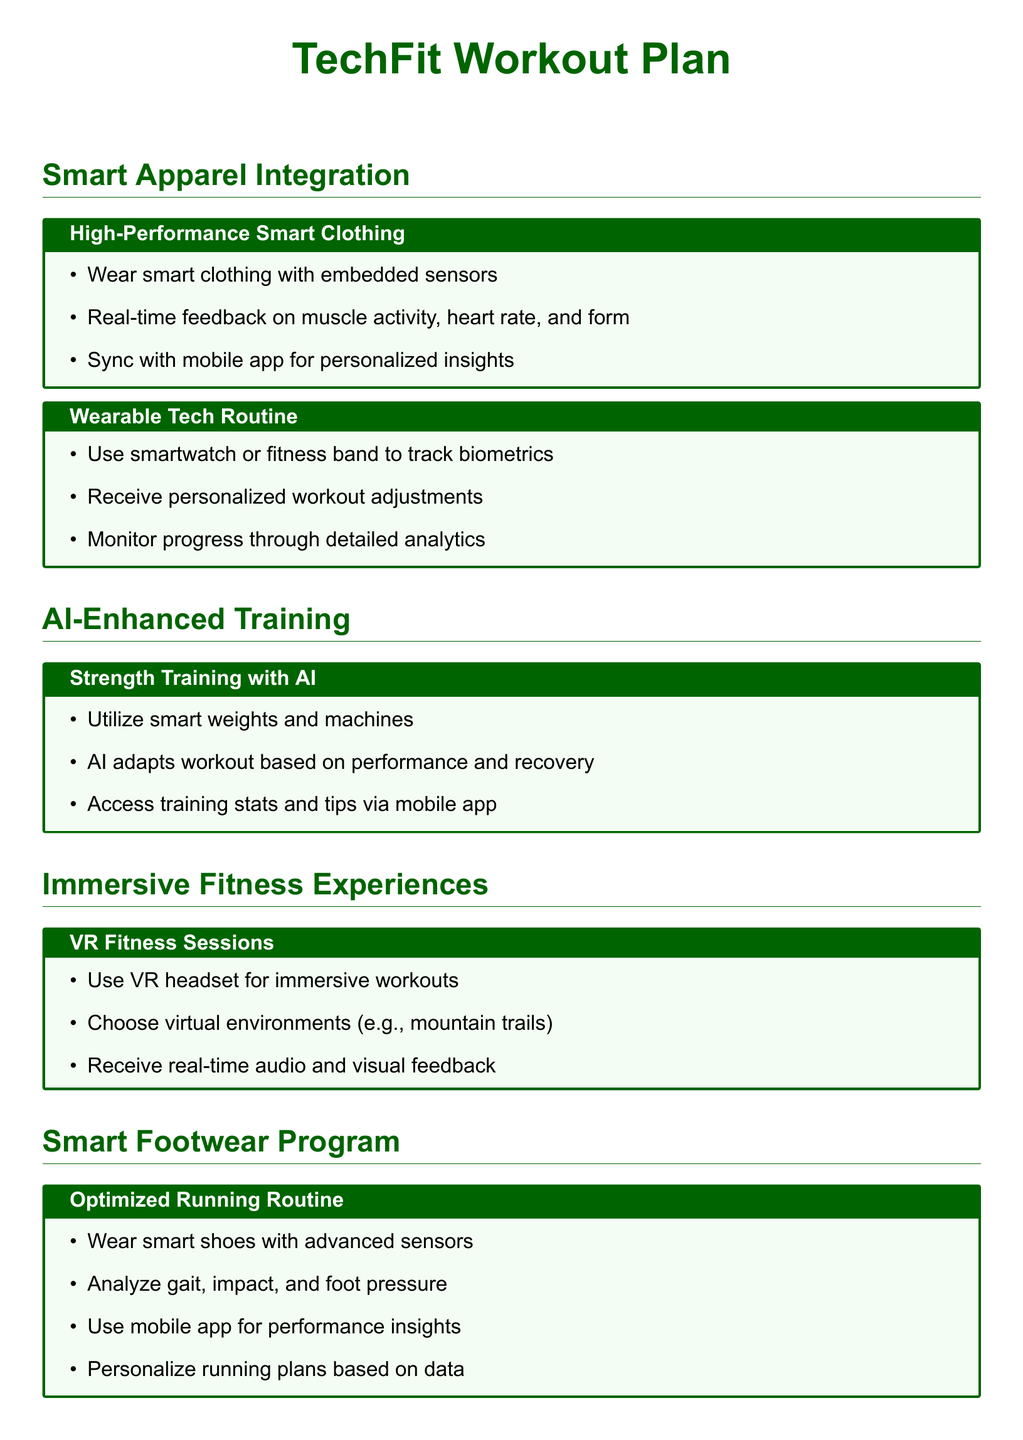What is the title of the document? The title of the document is presented at the top of the rendered document, which is "TechFit Workout Plan."
Answer: TechFit Workout Plan How many workout plans are mentioned? The document lists five distinct workout plans, each identified with a dedicated section.
Answer: Five What type of wearable is suggested for tracking biometrics? The document specifically mentions using a smartwatch or fitness band for tracking biometrics.
Answer: Smartwatch or fitness band What technology enhances the strength training protocol? The strength training protocol is enhanced by an AI-based coaching application.
Answer: AI-based coaching application What is analyzed using smart shoes in the running program? The smart shoes are designed to analyze gait, impact, and foot pressure during the running routine.
Answer: Gait, impact, and foot pressure Which immersive technology is used in the VR fitness sessions? The immersive technology mentioned for the VR fitness sessions is a VR headset.
Answer: VR headset What kind of feedback does smart clothing provide? Smart clothing provides real-time feedback on muscle activity, heart rate, and form during workouts.
Answer: Real-time feedback on muscle activity, heart rate, and form How does the AI in strength training adapt workouts? The AI adapts workouts based on the user's performance and recovery status.
Answer: User's performance and recovery status What platform is used to personalize running plans based on data? A mobile app is utilized to personalize running plans based on the data collected from the smart shoes.
Answer: Mobile app 